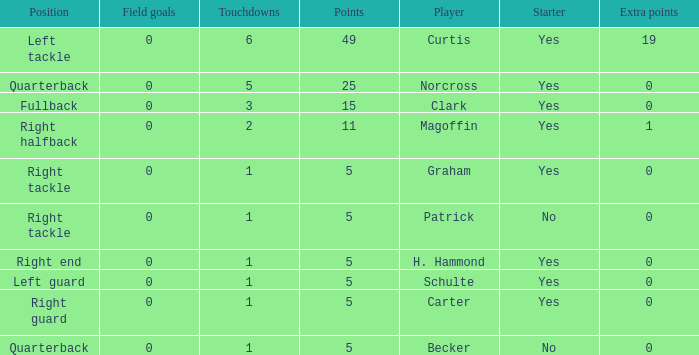Name the most touchdowns for becker  1.0. 